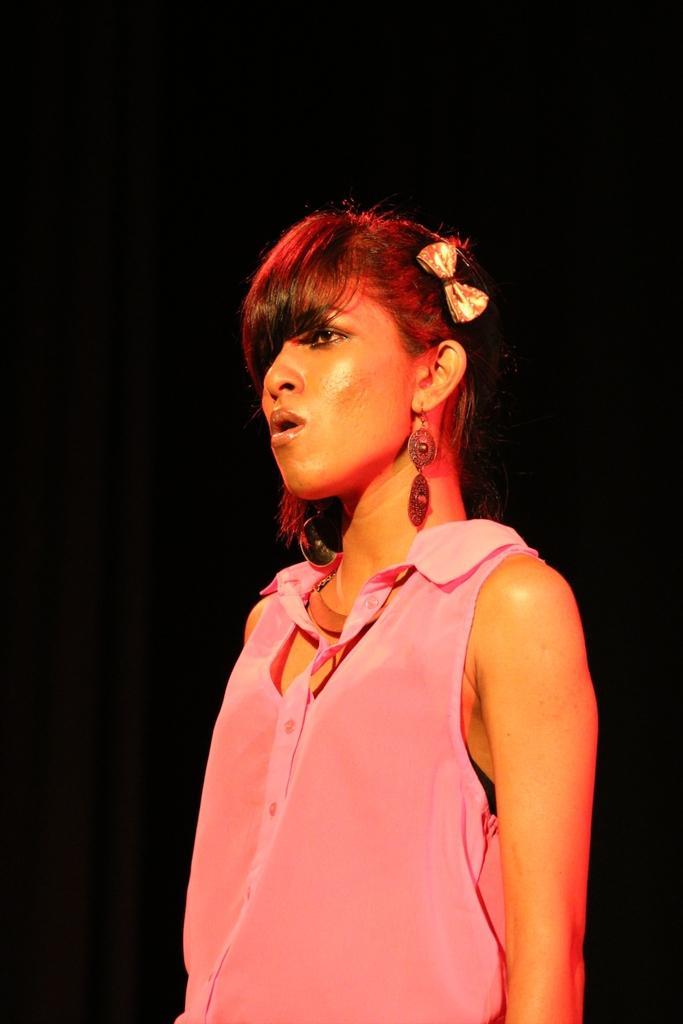How would you summarize this image in a sentence or two? In this image I can see the person standing and wearing the pink color dress. And I can see the black background. 